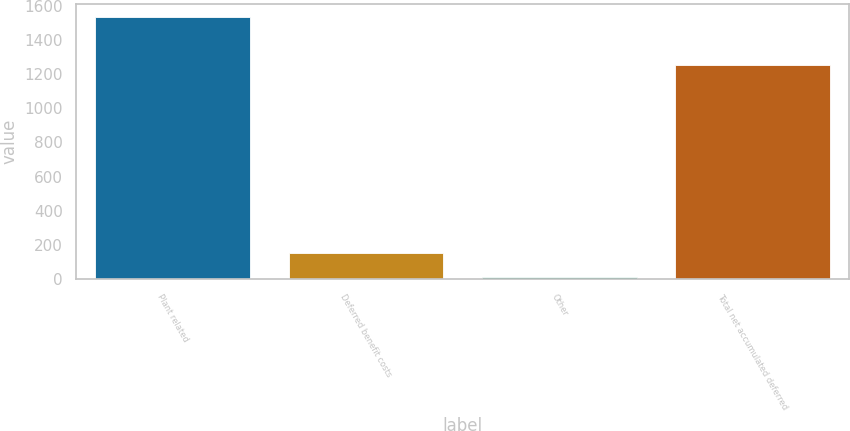Convert chart to OTSL. <chart><loc_0><loc_0><loc_500><loc_500><bar_chart><fcel>Plant related<fcel>Deferred benefit costs<fcel>Other<fcel>Total net accumulated deferred<nl><fcel>1535<fcel>153.5<fcel>12<fcel>1252<nl></chart> 